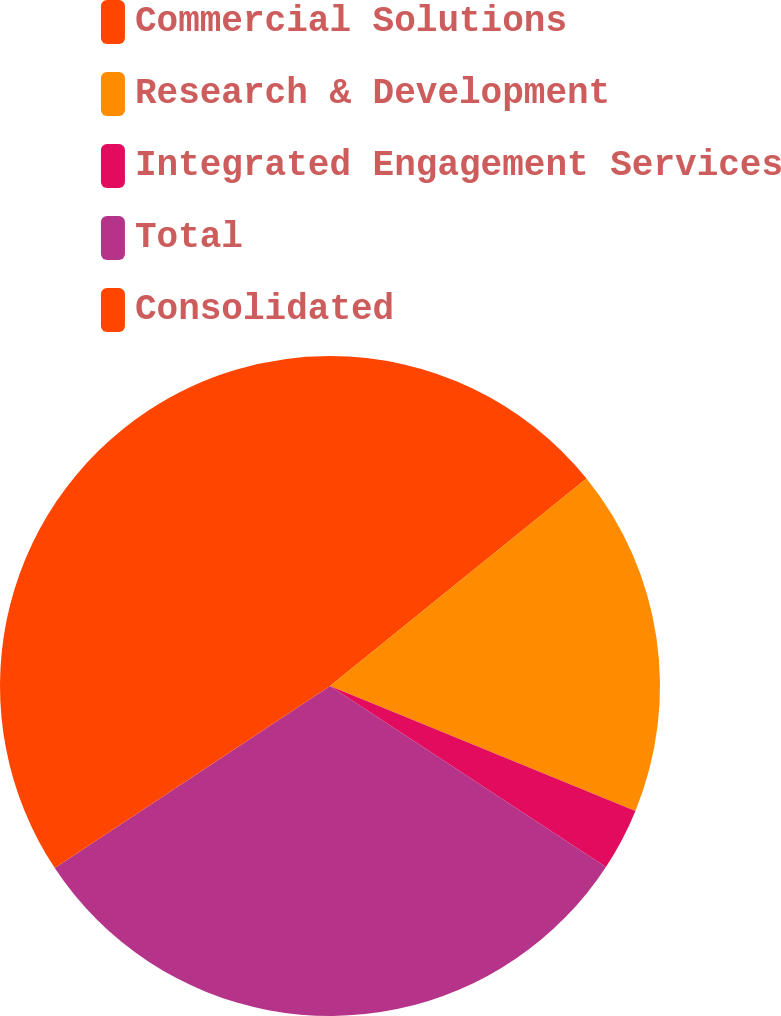Convert chart to OTSL. <chart><loc_0><loc_0><loc_500><loc_500><pie_chart><fcel>Commercial Solutions<fcel>Research & Development<fcel>Integrated Engagement Services<fcel>Total<fcel>Consolidated<nl><fcel>14.17%<fcel>17.01%<fcel>3.06%<fcel>31.46%<fcel>34.3%<nl></chart> 